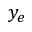<formula> <loc_0><loc_0><loc_500><loc_500>y _ { e }</formula> 